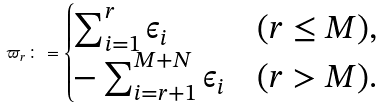Convert formula to latex. <formula><loc_0><loc_0><loc_500><loc_500>\varpi _ { r } \colon = \begin{cases} \sum _ { i = 1 } ^ { r } \epsilon _ { i } & ( r \leq M ) , \\ - \sum _ { i = r + 1 } ^ { M + N } \epsilon _ { i } & ( r > M ) . \end{cases}</formula> 